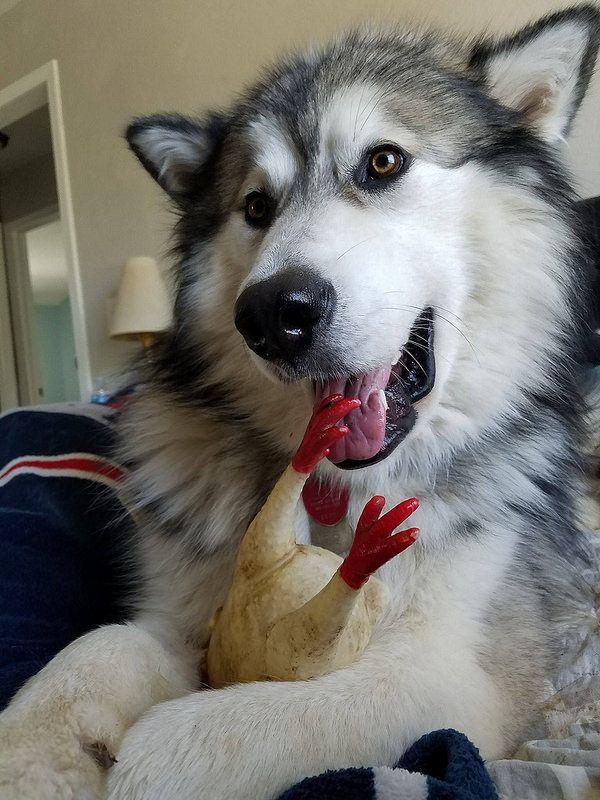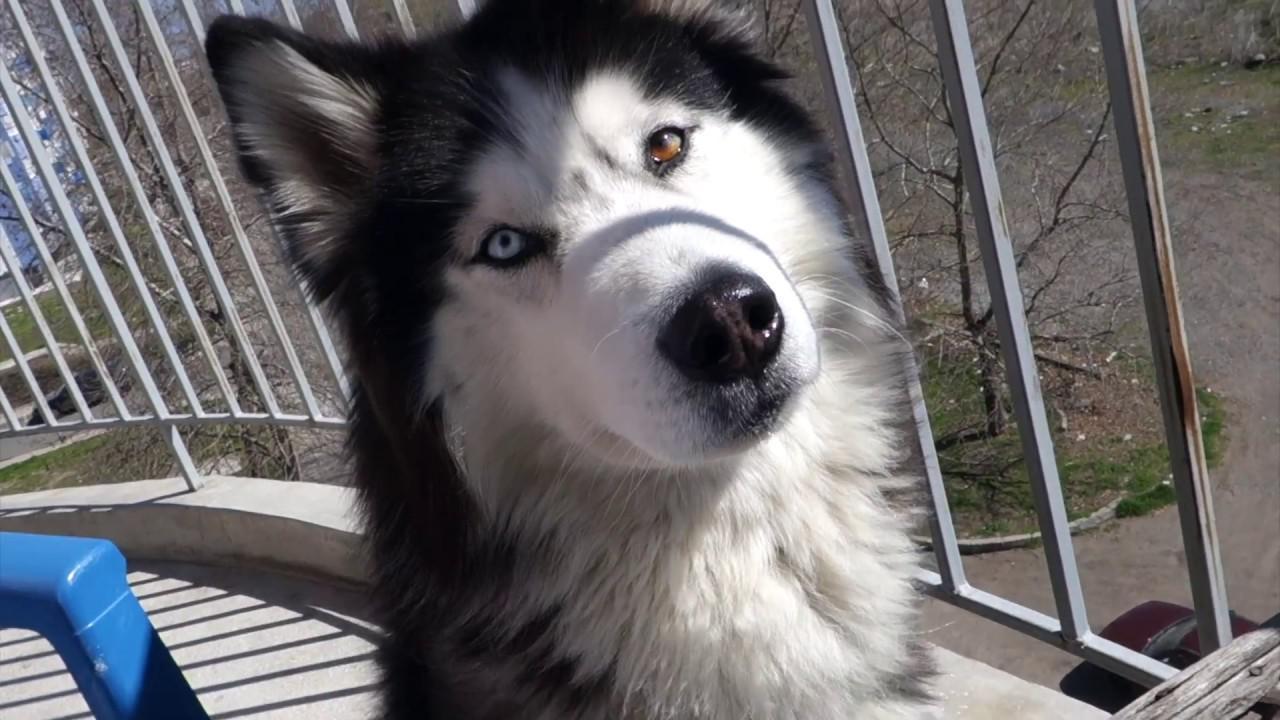The first image is the image on the left, the second image is the image on the right. Examine the images to the left and right. Is the description "One of the dogs is brown and white." accurate? Answer yes or no. No. The first image is the image on the left, the second image is the image on the right. Evaluate the accuracy of this statement regarding the images: "Three or more mammals are visible.". Is it true? Answer yes or no. No. 